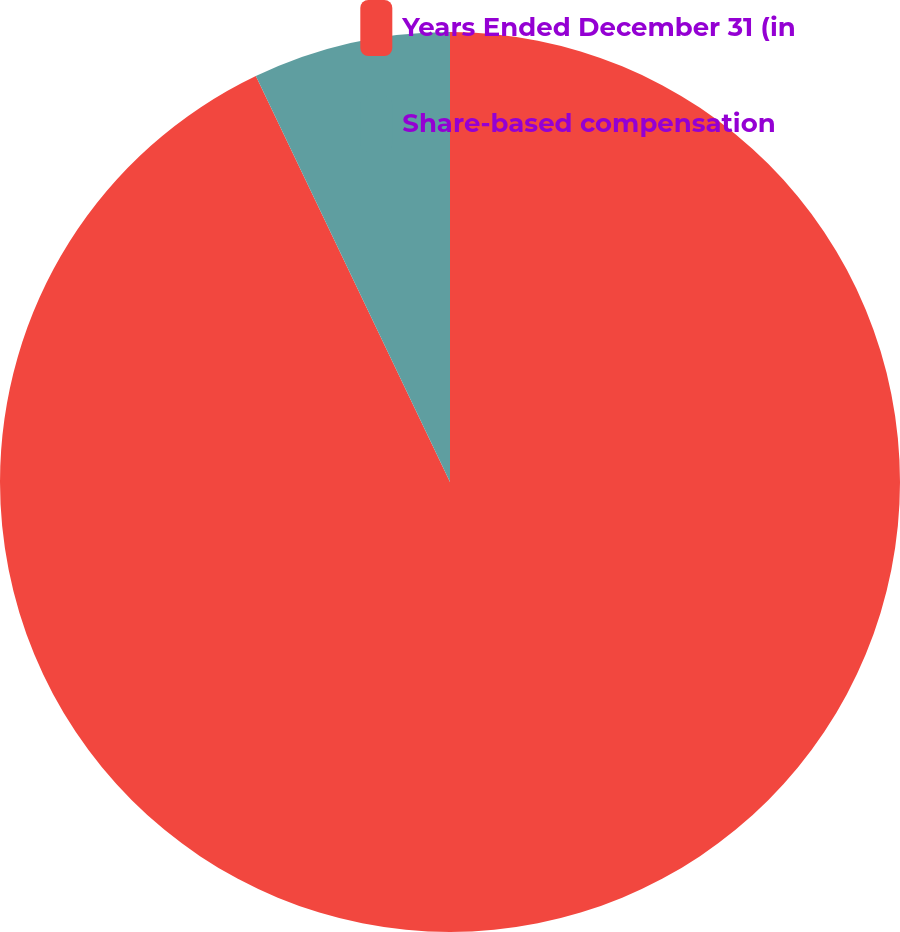Convert chart to OTSL. <chart><loc_0><loc_0><loc_500><loc_500><pie_chart><fcel>Years Ended December 31 (in<fcel>Share-based compensation<nl><fcel>92.9%<fcel>7.1%<nl></chart> 